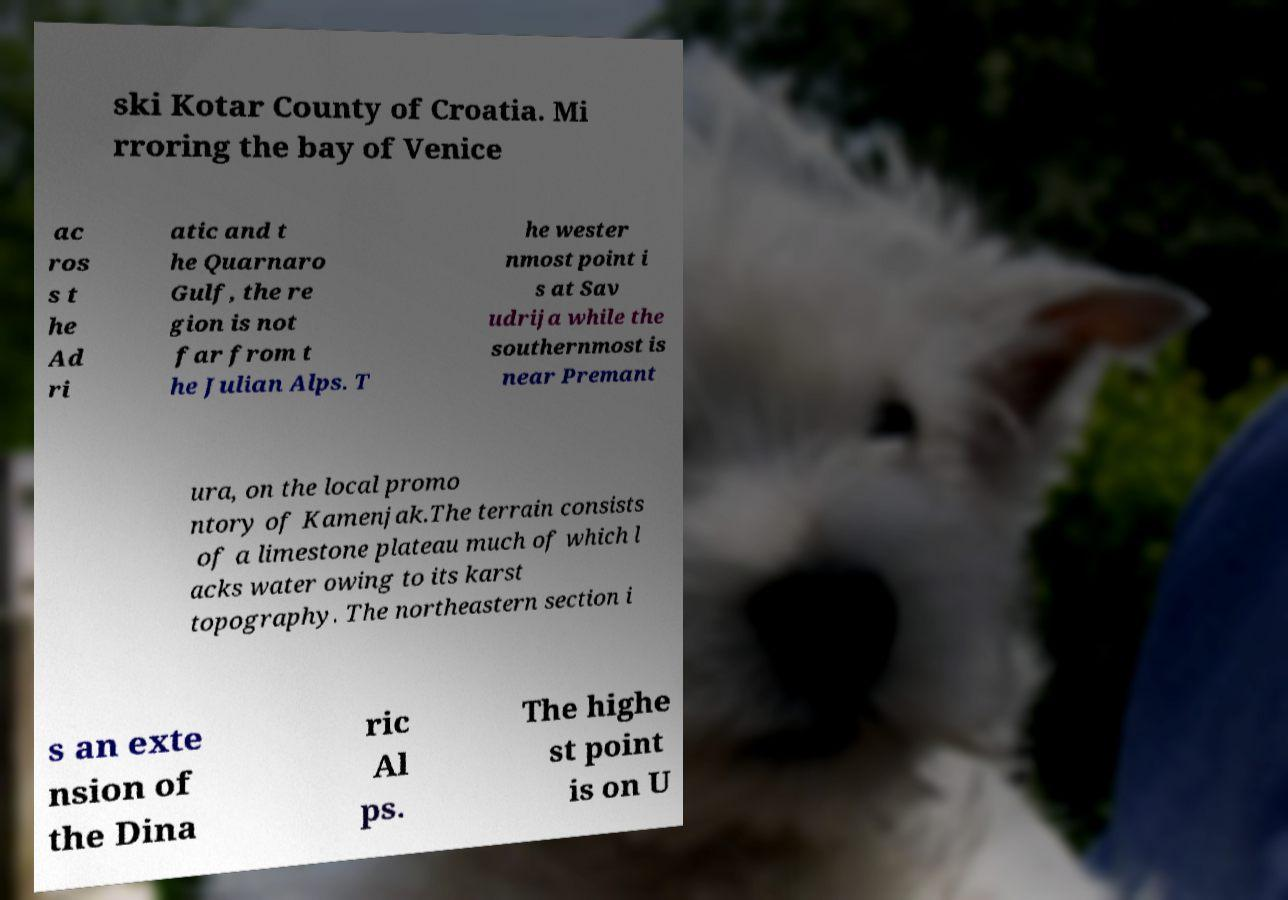Could you extract and type out the text from this image? ski Kotar County of Croatia. Mi rroring the bay of Venice ac ros s t he Ad ri atic and t he Quarnaro Gulf, the re gion is not far from t he Julian Alps. T he wester nmost point i s at Sav udrija while the southernmost is near Premant ura, on the local promo ntory of Kamenjak.The terrain consists of a limestone plateau much of which l acks water owing to its karst topography. The northeastern section i s an exte nsion of the Dina ric Al ps. The highe st point is on U 